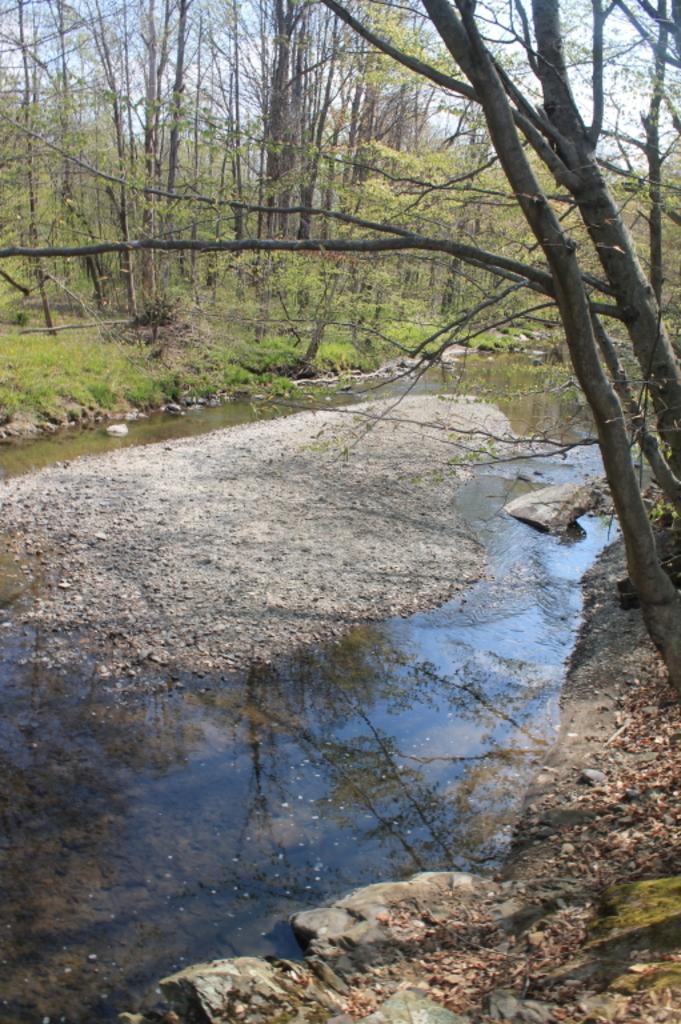In one or two sentences, can you explain what this image depicts? There is a lake in the picture which is almost dried and there is some sand at the center of the lake and the background, we can observe some trees there, looking like a forest. There is a sky. In the lake some stones are presented. 